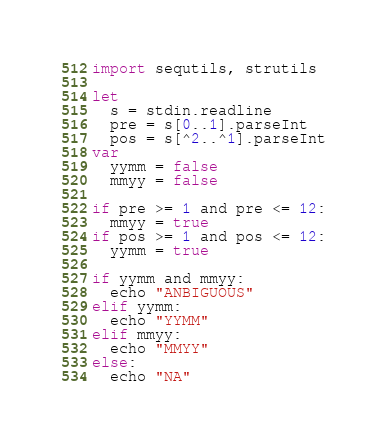Convert code to text. <code><loc_0><loc_0><loc_500><loc_500><_Nim_>import sequtils, strutils

let
  s = stdin.readline
  pre = s[0..1].parseInt
  pos = s[^2..^1].parseInt
var
  yymm = false
  mmyy = false

if pre >= 1 and pre <= 12:
  mmyy = true
if pos >= 1 and pos <= 12:
  yymm = true

if yymm and mmyy:
  echo "ANBIGUOUS"
elif yymm:
  echo "YYMM"
elif mmyy:
  echo "MMYY"
else:
  echo "NA"
</code> 